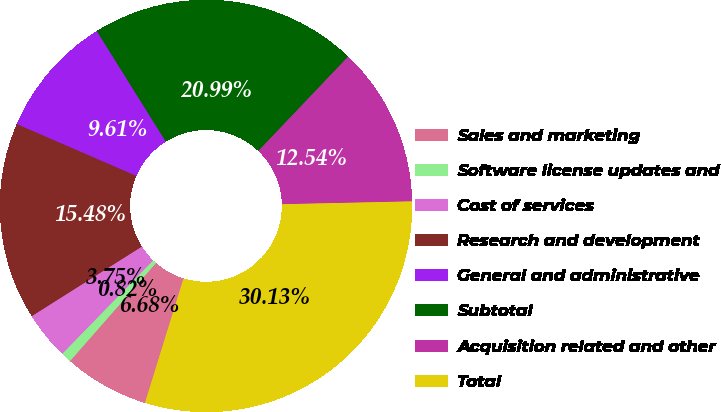Convert chart. <chart><loc_0><loc_0><loc_500><loc_500><pie_chart><fcel>Sales and marketing<fcel>Software license updates and<fcel>Cost of services<fcel>Research and development<fcel>General and administrative<fcel>Subtotal<fcel>Acquisition related and other<fcel>Total<nl><fcel>6.68%<fcel>0.82%<fcel>3.75%<fcel>15.48%<fcel>9.61%<fcel>20.99%<fcel>12.54%<fcel>30.13%<nl></chart> 